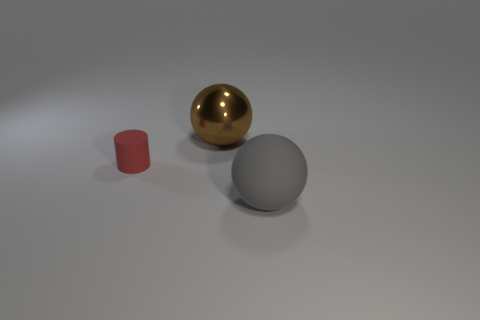Are there any other things that are the same size as the red object?
Offer a very short reply. No. What number of spheres are tiny brown matte objects or large brown objects?
Your answer should be very brief. 1. How many big brown objects are the same shape as the red object?
Your answer should be compact. 0. Is the number of metal spheres behind the large rubber ball greater than the number of large brown metallic balls in front of the shiny thing?
Your response must be concise. Yes. How big is the rubber sphere?
Keep it short and to the point. Large. There is a gray object that is the same size as the brown sphere; what is it made of?
Provide a succinct answer. Rubber. The large sphere that is behind the cylinder is what color?
Make the answer very short. Brown. How many small blue cylinders are there?
Your answer should be compact. 0. There is a large object that is right of the big sphere behind the gray ball; are there any red matte cylinders on the left side of it?
Your answer should be compact. Yes. The gray matte thing that is the same size as the brown metal ball is what shape?
Make the answer very short. Sphere. 